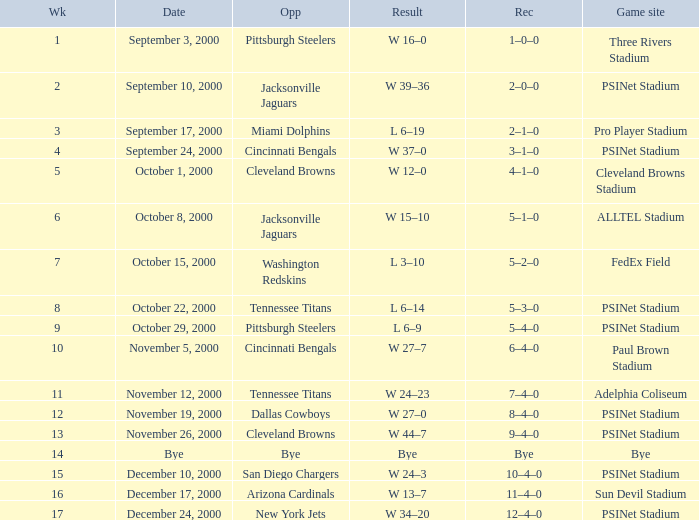What game site has a result of bye? Bye. 